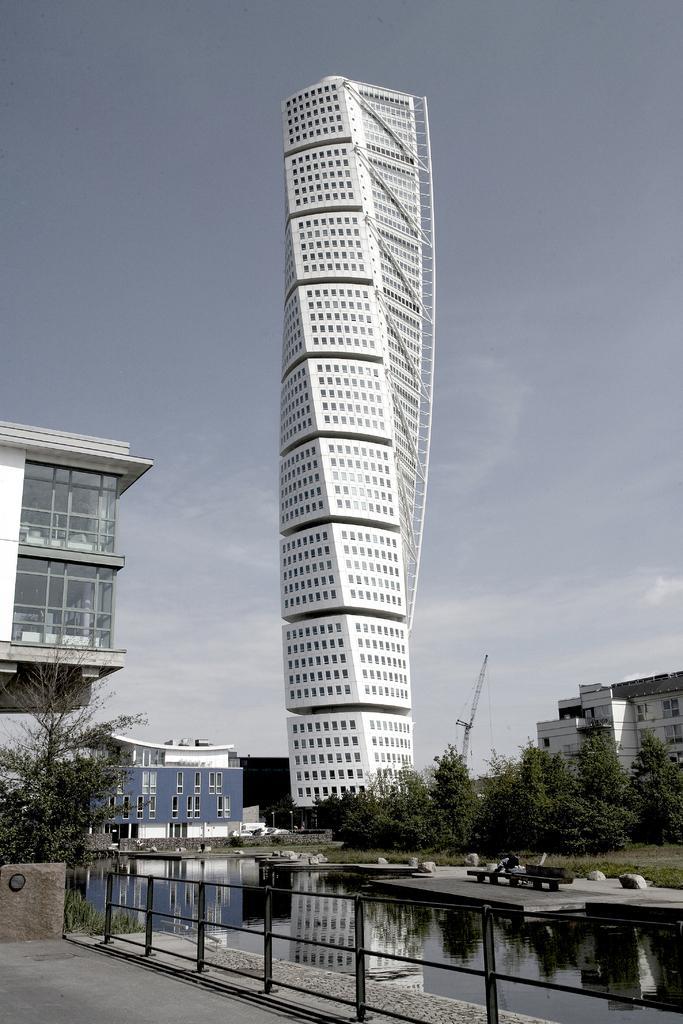In one or two sentences, can you explain what this image depicts? In this picture we can see buildings here, at the bottom there is water, we can see a bench here, there is a railing here, we can see some trees, there is the sky at the top of the picture. 